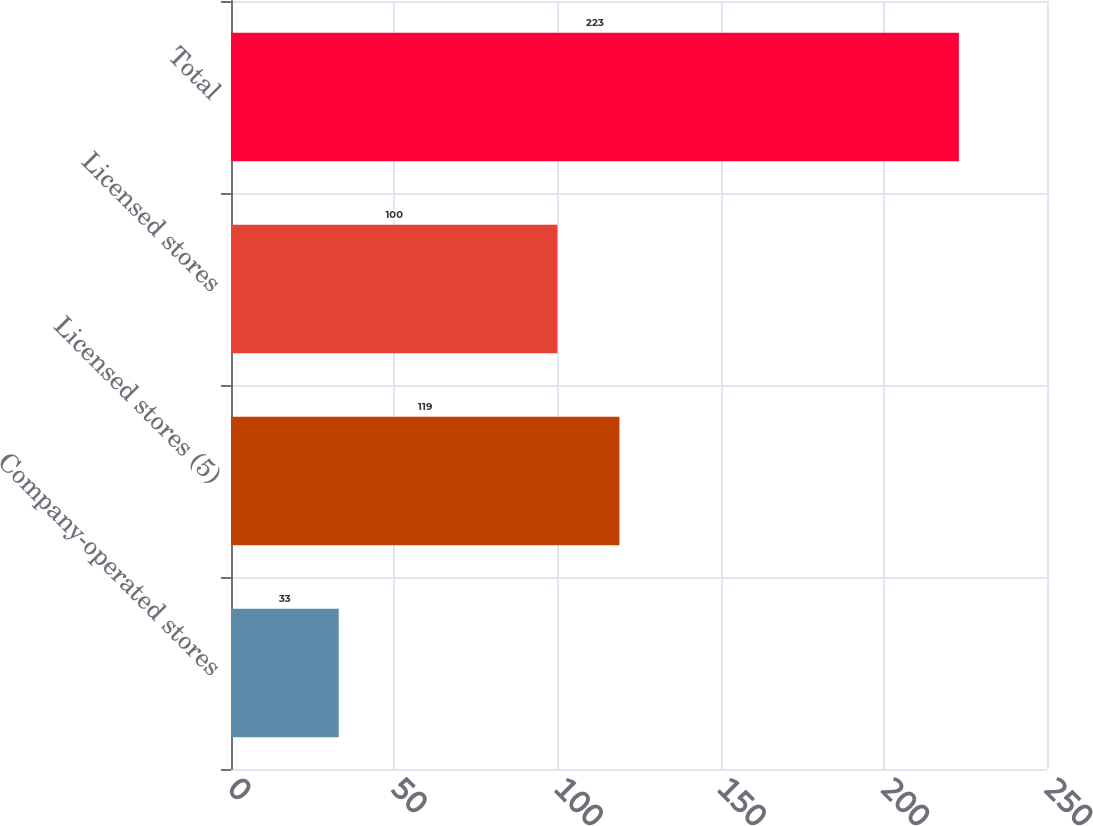Convert chart to OTSL. <chart><loc_0><loc_0><loc_500><loc_500><bar_chart><fcel>Company-operated stores<fcel>Licensed stores (5)<fcel>Licensed stores<fcel>Total<nl><fcel>33<fcel>119<fcel>100<fcel>223<nl></chart> 